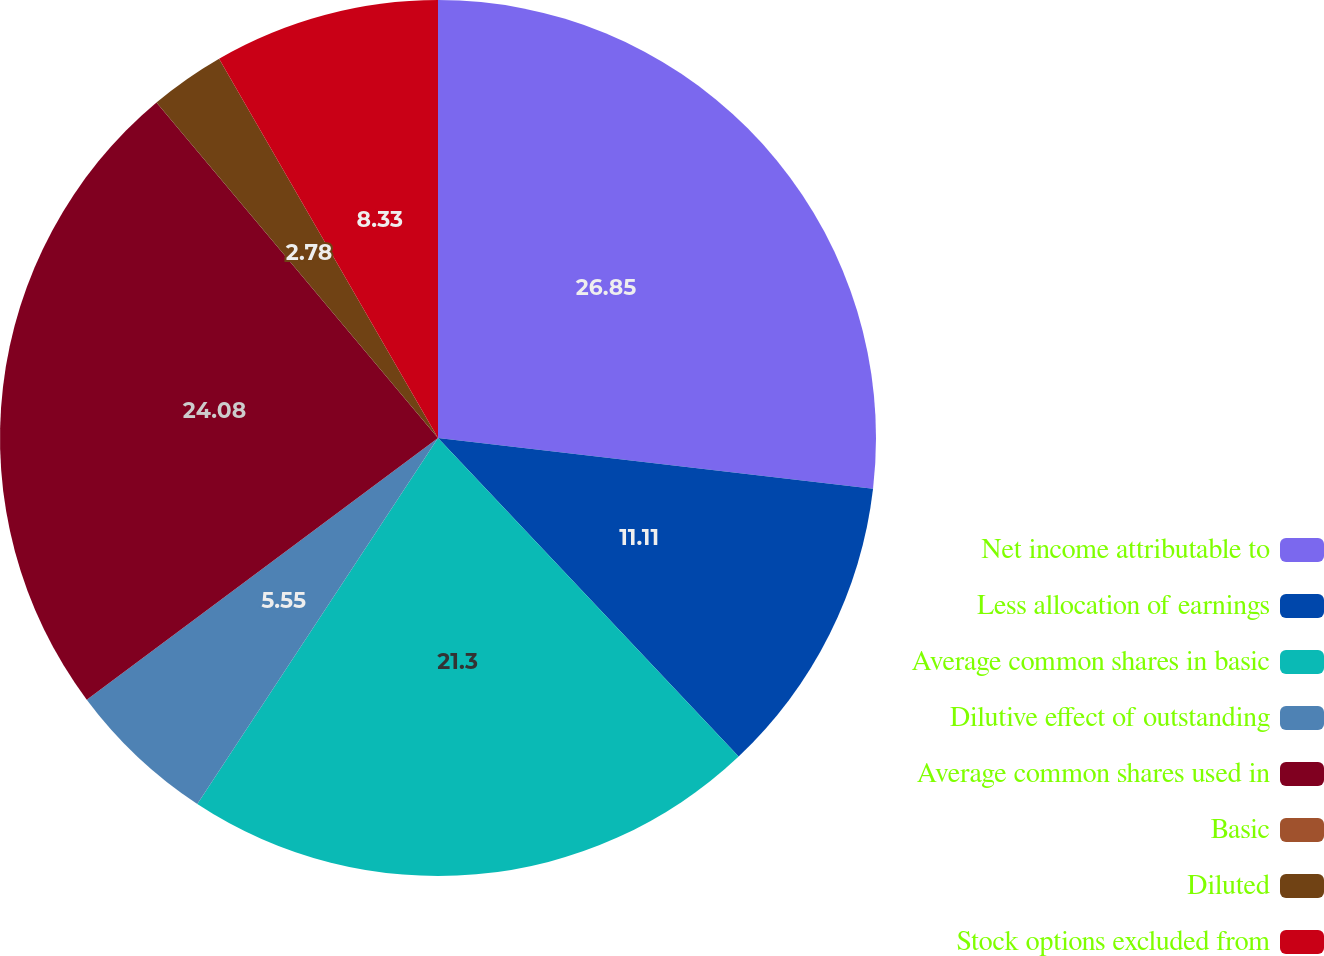<chart> <loc_0><loc_0><loc_500><loc_500><pie_chart><fcel>Net income attributable to<fcel>Less allocation of earnings<fcel>Average common shares in basic<fcel>Dilutive effect of outstanding<fcel>Average common shares used in<fcel>Basic<fcel>Diluted<fcel>Stock options excluded from<nl><fcel>26.85%<fcel>11.11%<fcel>21.3%<fcel>5.55%<fcel>24.08%<fcel>0.0%<fcel>2.78%<fcel>8.33%<nl></chart> 